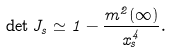<formula> <loc_0><loc_0><loc_500><loc_500>\det J _ { s } \simeq 1 - \frac { m ^ { 2 } ( \infty ) } { x _ { s } ^ { 4 } } .</formula> 